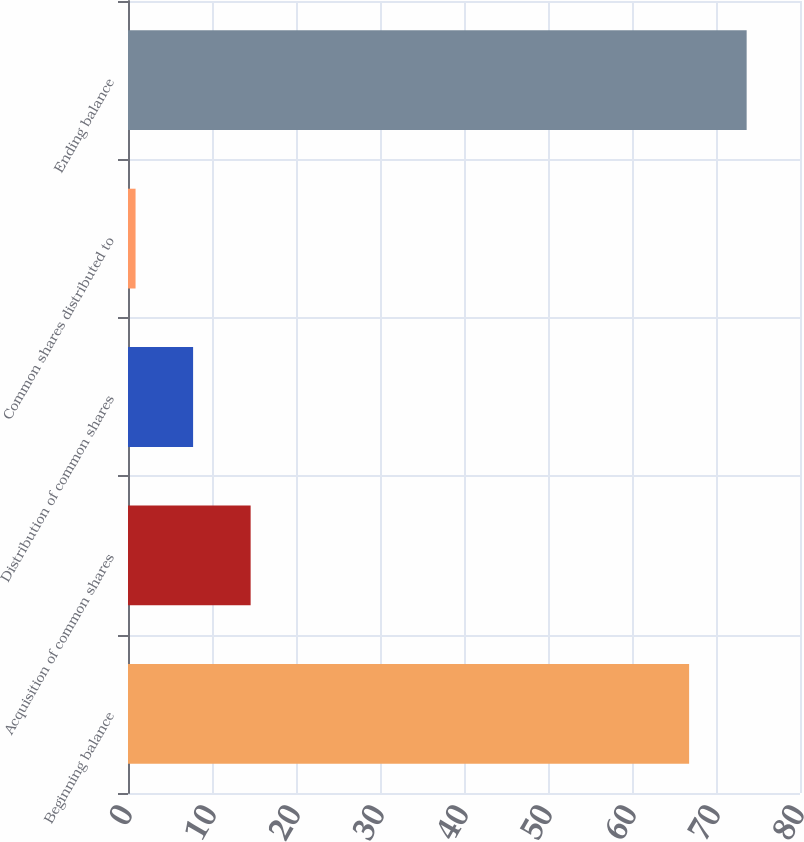Convert chart to OTSL. <chart><loc_0><loc_0><loc_500><loc_500><bar_chart><fcel>Beginning balance<fcel>Acquisition of common shares<fcel>Distribution of common shares<fcel>Common shares distributed to<fcel>Ending balance<nl><fcel>66.8<fcel>14.6<fcel>7.75<fcel>0.9<fcel>73.65<nl></chart> 